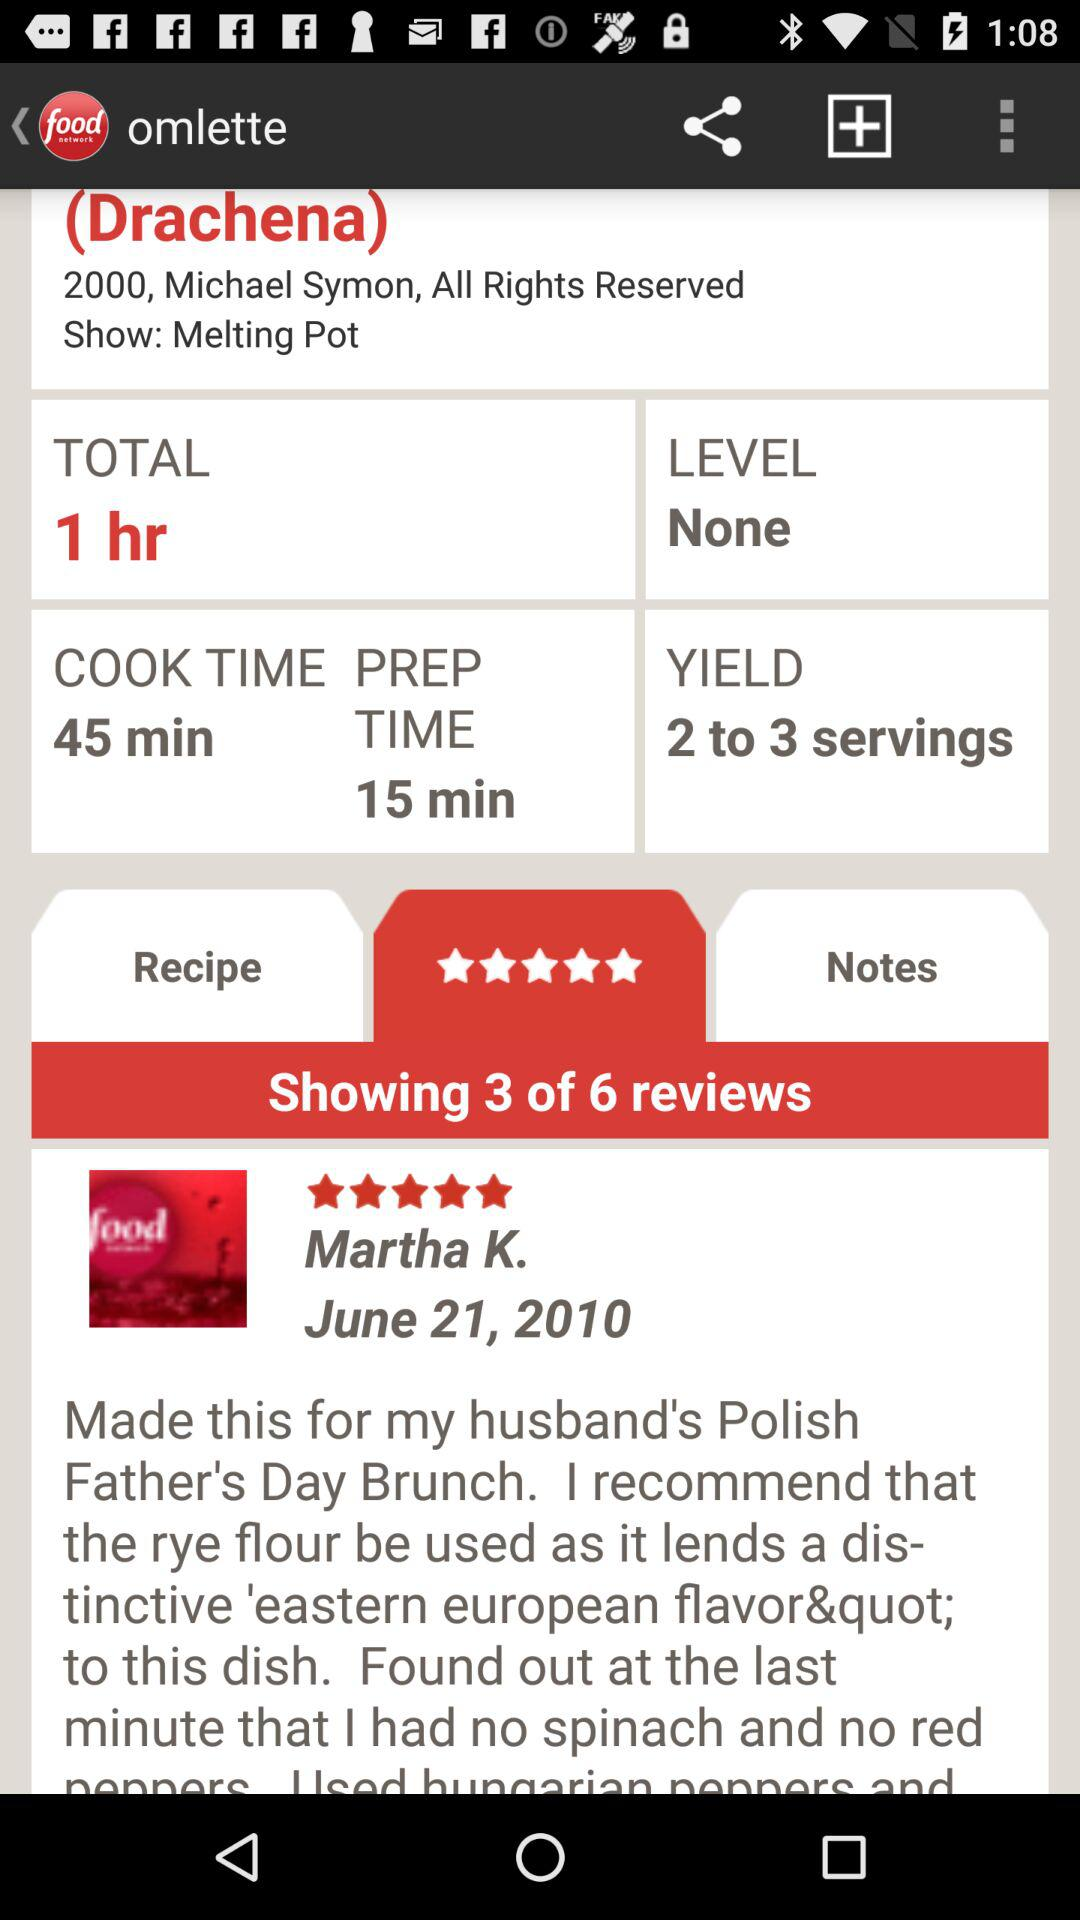How much time will "Drachena" take in total? "Drachena" will take 1 hour in total. 